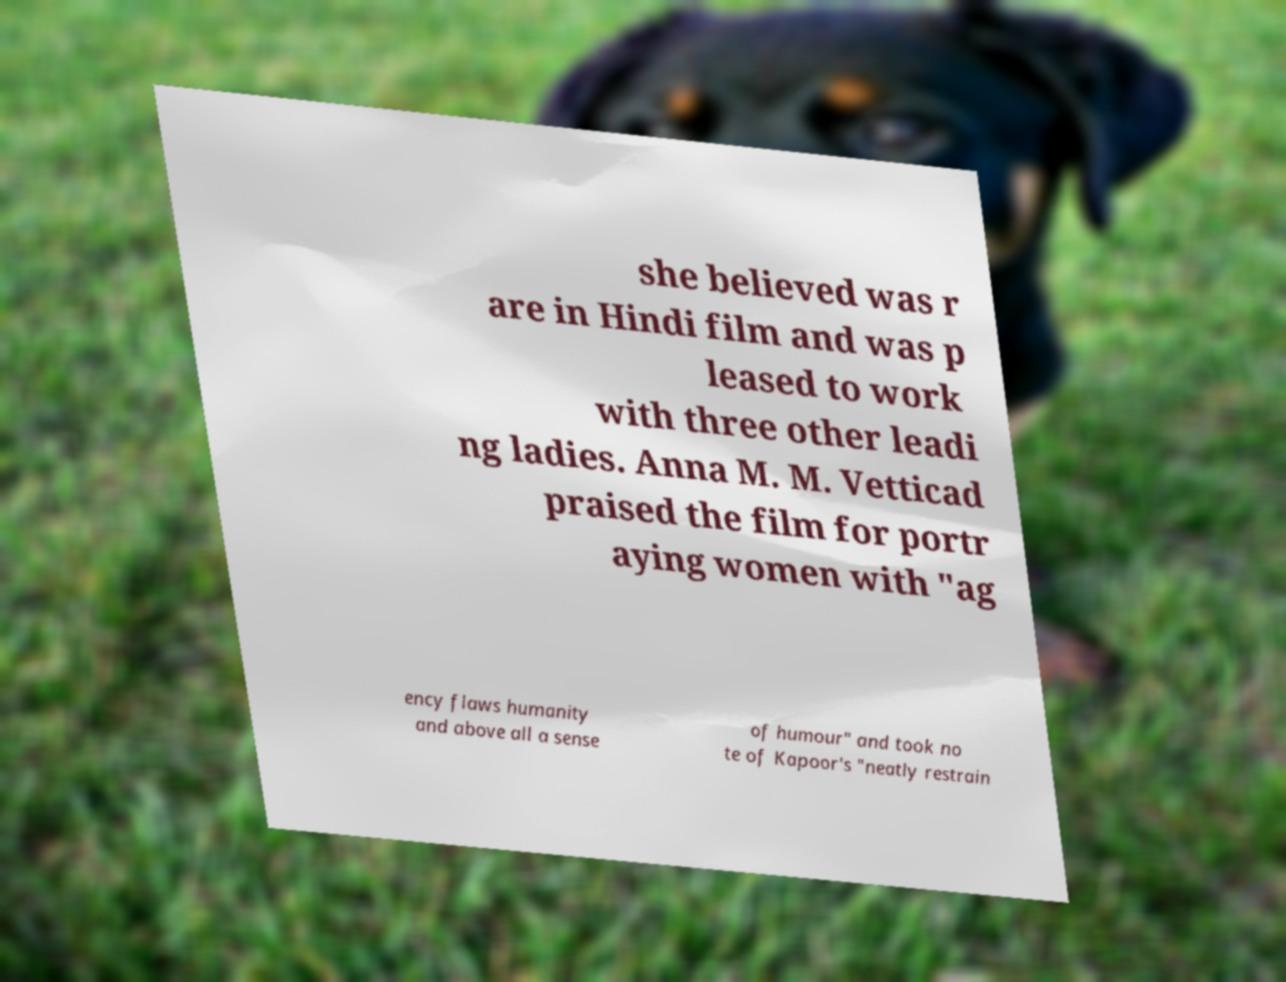I need the written content from this picture converted into text. Can you do that? she believed was r are in Hindi film and was p leased to work with three other leadi ng ladies. Anna M. M. Vetticad praised the film for portr aying women with "ag ency flaws humanity and above all a sense of humour" and took no te of Kapoor's "neatly restrain 